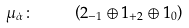Convert formula to latex. <formula><loc_0><loc_0><loc_500><loc_500>\mu _ { \dot { \alpha } } \colon \quad \left ( 2 _ { - 1 } \oplus 1 _ { + 2 } \oplus 1 _ { 0 } \right )</formula> 